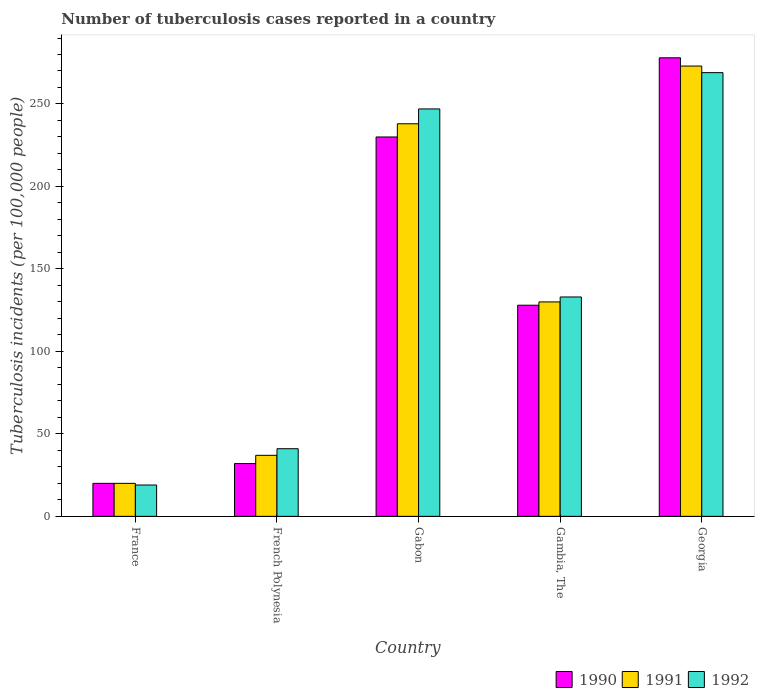How many bars are there on the 5th tick from the left?
Your answer should be very brief. 3. How many bars are there on the 3rd tick from the right?
Provide a short and direct response. 3. What is the label of the 4th group of bars from the left?
Ensure brevity in your answer.  Gambia, The. In how many cases, is the number of bars for a given country not equal to the number of legend labels?
Your answer should be very brief. 0. What is the number of tuberculosis cases reported in in 1990 in Gambia, The?
Provide a short and direct response. 128. Across all countries, what is the maximum number of tuberculosis cases reported in in 1991?
Keep it short and to the point. 273. In which country was the number of tuberculosis cases reported in in 1992 maximum?
Give a very brief answer. Georgia. What is the total number of tuberculosis cases reported in in 1991 in the graph?
Ensure brevity in your answer.  698. What is the difference between the number of tuberculosis cases reported in in 1990 in Gambia, The and that in Georgia?
Keep it short and to the point. -150. What is the difference between the number of tuberculosis cases reported in in 1990 in France and the number of tuberculosis cases reported in in 1992 in Georgia?
Offer a very short reply. -249. What is the average number of tuberculosis cases reported in in 1992 per country?
Make the answer very short. 141.8. What is the ratio of the number of tuberculosis cases reported in in 1991 in France to that in French Polynesia?
Ensure brevity in your answer.  0.54. Is the difference between the number of tuberculosis cases reported in in 1991 in France and Georgia greater than the difference between the number of tuberculosis cases reported in in 1992 in France and Georgia?
Provide a short and direct response. No. What is the difference between the highest and the second highest number of tuberculosis cases reported in in 1992?
Give a very brief answer. 136. What is the difference between the highest and the lowest number of tuberculosis cases reported in in 1991?
Provide a succinct answer. 253. In how many countries, is the number of tuberculosis cases reported in in 1990 greater than the average number of tuberculosis cases reported in in 1990 taken over all countries?
Offer a very short reply. 2. What does the 3rd bar from the right in Gambia, The represents?
Your answer should be very brief. 1990. Is it the case that in every country, the sum of the number of tuberculosis cases reported in in 1992 and number of tuberculosis cases reported in in 1991 is greater than the number of tuberculosis cases reported in in 1990?
Make the answer very short. Yes. What is the difference between two consecutive major ticks on the Y-axis?
Provide a succinct answer. 50. Are the values on the major ticks of Y-axis written in scientific E-notation?
Keep it short and to the point. No. Where does the legend appear in the graph?
Provide a short and direct response. Bottom right. How many legend labels are there?
Your response must be concise. 3. How are the legend labels stacked?
Your answer should be compact. Horizontal. What is the title of the graph?
Keep it short and to the point. Number of tuberculosis cases reported in a country. Does "1983" appear as one of the legend labels in the graph?
Provide a short and direct response. No. What is the label or title of the Y-axis?
Your answer should be very brief. Tuberculosis incidents (per 100,0 people). What is the Tuberculosis incidents (per 100,000 people) in 1990 in French Polynesia?
Keep it short and to the point. 32. What is the Tuberculosis incidents (per 100,000 people) of 1992 in French Polynesia?
Offer a very short reply. 41. What is the Tuberculosis incidents (per 100,000 people) in 1990 in Gabon?
Offer a very short reply. 230. What is the Tuberculosis incidents (per 100,000 people) of 1991 in Gabon?
Your response must be concise. 238. What is the Tuberculosis incidents (per 100,000 people) in 1992 in Gabon?
Offer a terse response. 247. What is the Tuberculosis incidents (per 100,000 people) in 1990 in Gambia, The?
Provide a succinct answer. 128. What is the Tuberculosis incidents (per 100,000 people) in 1991 in Gambia, The?
Your answer should be very brief. 130. What is the Tuberculosis incidents (per 100,000 people) in 1992 in Gambia, The?
Ensure brevity in your answer.  133. What is the Tuberculosis incidents (per 100,000 people) in 1990 in Georgia?
Offer a very short reply. 278. What is the Tuberculosis incidents (per 100,000 people) of 1991 in Georgia?
Your response must be concise. 273. What is the Tuberculosis incidents (per 100,000 people) in 1992 in Georgia?
Provide a short and direct response. 269. Across all countries, what is the maximum Tuberculosis incidents (per 100,000 people) of 1990?
Ensure brevity in your answer.  278. Across all countries, what is the maximum Tuberculosis incidents (per 100,000 people) of 1991?
Offer a very short reply. 273. Across all countries, what is the maximum Tuberculosis incidents (per 100,000 people) of 1992?
Keep it short and to the point. 269. Across all countries, what is the minimum Tuberculosis incidents (per 100,000 people) of 1992?
Make the answer very short. 19. What is the total Tuberculosis incidents (per 100,000 people) of 1990 in the graph?
Give a very brief answer. 688. What is the total Tuberculosis incidents (per 100,000 people) of 1991 in the graph?
Make the answer very short. 698. What is the total Tuberculosis incidents (per 100,000 people) of 1992 in the graph?
Offer a very short reply. 709. What is the difference between the Tuberculosis incidents (per 100,000 people) in 1990 in France and that in French Polynesia?
Your answer should be compact. -12. What is the difference between the Tuberculosis incidents (per 100,000 people) in 1991 in France and that in French Polynesia?
Your answer should be compact. -17. What is the difference between the Tuberculosis incidents (per 100,000 people) of 1992 in France and that in French Polynesia?
Offer a very short reply. -22. What is the difference between the Tuberculosis incidents (per 100,000 people) in 1990 in France and that in Gabon?
Make the answer very short. -210. What is the difference between the Tuberculosis incidents (per 100,000 people) of 1991 in France and that in Gabon?
Provide a succinct answer. -218. What is the difference between the Tuberculosis incidents (per 100,000 people) of 1992 in France and that in Gabon?
Give a very brief answer. -228. What is the difference between the Tuberculosis incidents (per 100,000 people) in 1990 in France and that in Gambia, The?
Provide a succinct answer. -108. What is the difference between the Tuberculosis incidents (per 100,000 people) in 1991 in France and that in Gambia, The?
Make the answer very short. -110. What is the difference between the Tuberculosis incidents (per 100,000 people) of 1992 in France and that in Gambia, The?
Provide a succinct answer. -114. What is the difference between the Tuberculosis incidents (per 100,000 people) of 1990 in France and that in Georgia?
Ensure brevity in your answer.  -258. What is the difference between the Tuberculosis incidents (per 100,000 people) of 1991 in France and that in Georgia?
Provide a short and direct response. -253. What is the difference between the Tuberculosis incidents (per 100,000 people) in 1992 in France and that in Georgia?
Keep it short and to the point. -250. What is the difference between the Tuberculosis incidents (per 100,000 people) of 1990 in French Polynesia and that in Gabon?
Offer a terse response. -198. What is the difference between the Tuberculosis incidents (per 100,000 people) of 1991 in French Polynesia and that in Gabon?
Keep it short and to the point. -201. What is the difference between the Tuberculosis incidents (per 100,000 people) in 1992 in French Polynesia and that in Gabon?
Provide a short and direct response. -206. What is the difference between the Tuberculosis incidents (per 100,000 people) of 1990 in French Polynesia and that in Gambia, The?
Keep it short and to the point. -96. What is the difference between the Tuberculosis incidents (per 100,000 people) of 1991 in French Polynesia and that in Gambia, The?
Your response must be concise. -93. What is the difference between the Tuberculosis incidents (per 100,000 people) of 1992 in French Polynesia and that in Gambia, The?
Offer a very short reply. -92. What is the difference between the Tuberculosis incidents (per 100,000 people) of 1990 in French Polynesia and that in Georgia?
Your response must be concise. -246. What is the difference between the Tuberculosis incidents (per 100,000 people) in 1991 in French Polynesia and that in Georgia?
Provide a succinct answer. -236. What is the difference between the Tuberculosis incidents (per 100,000 people) of 1992 in French Polynesia and that in Georgia?
Make the answer very short. -228. What is the difference between the Tuberculosis incidents (per 100,000 people) in 1990 in Gabon and that in Gambia, The?
Provide a succinct answer. 102. What is the difference between the Tuberculosis incidents (per 100,000 people) of 1991 in Gabon and that in Gambia, The?
Offer a terse response. 108. What is the difference between the Tuberculosis incidents (per 100,000 people) of 1992 in Gabon and that in Gambia, The?
Offer a very short reply. 114. What is the difference between the Tuberculosis incidents (per 100,000 people) in 1990 in Gabon and that in Georgia?
Provide a short and direct response. -48. What is the difference between the Tuberculosis incidents (per 100,000 people) in 1991 in Gabon and that in Georgia?
Give a very brief answer. -35. What is the difference between the Tuberculosis incidents (per 100,000 people) in 1990 in Gambia, The and that in Georgia?
Provide a short and direct response. -150. What is the difference between the Tuberculosis incidents (per 100,000 people) of 1991 in Gambia, The and that in Georgia?
Make the answer very short. -143. What is the difference between the Tuberculosis incidents (per 100,000 people) in 1992 in Gambia, The and that in Georgia?
Your answer should be compact. -136. What is the difference between the Tuberculosis incidents (per 100,000 people) in 1990 in France and the Tuberculosis incidents (per 100,000 people) in 1991 in French Polynesia?
Your answer should be very brief. -17. What is the difference between the Tuberculosis incidents (per 100,000 people) of 1990 in France and the Tuberculosis incidents (per 100,000 people) of 1991 in Gabon?
Make the answer very short. -218. What is the difference between the Tuberculosis incidents (per 100,000 people) of 1990 in France and the Tuberculosis incidents (per 100,000 people) of 1992 in Gabon?
Your answer should be compact. -227. What is the difference between the Tuberculosis incidents (per 100,000 people) in 1991 in France and the Tuberculosis incidents (per 100,000 people) in 1992 in Gabon?
Keep it short and to the point. -227. What is the difference between the Tuberculosis incidents (per 100,000 people) of 1990 in France and the Tuberculosis incidents (per 100,000 people) of 1991 in Gambia, The?
Your answer should be compact. -110. What is the difference between the Tuberculosis incidents (per 100,000 people) of 1990 in France and the Tuberculosis incidents (per 100,000 people) of 1992 in Gambia, The?
Provide a succinct answer. -113. What is the difference between the Tuberculosis incidents (per 100,000 people) of 1991 in France and the Tuberculosis incidents (per 100,000 people) of 1992 in Gambia, The?
Keep it short and to the point. -113. What is the difference between the Tuberculosis incidents (per 100,000 people) in 1990 in France and the Tuberculosis incidents (per 100,000 people) in 1991 in Georgia?
Your answer should be very brief. -253. What is the difference between the Tuberculosis incidents (per 100,000 people) of 1990 in France and the Tuberculosis incidents (per 100,000 people) of 1992 in Georgia?
Your answer should be very brief. -249. What is the difference between the Tuberculosis incidents (per 100,000 people) of 1991 in France and the Tuberculosis incidents (per 100,000 people) of 1992 in Georgia?
Offer a terse response. -249. What is the difference between the Tuberculosis incidents (per 100,000 people) in 1990 in French Polynesia and the Tuberculosis incidents (per 100,000 people) in 1991 in Gabon?
Offer a terse response. -206. What is the difference between the Tuberculosis incidents (per 100,000 people) in 1990 in French Polynesia and the Tuberculosis incidents (per 100,000 people) in 1992 in Gabon?
Keep it short and to the point. -215. What is the difference between the Tuberculosis incidents (per 100,000 people) in 1991 in French Polynesia and the Tuberculosis incidents (per 100,000 people) in 1992 in Gabon?
Offer a very short reply. -210. What is the difference between the Tuberculosis incidents (per 100,000 people) in 1990 in French Polynesia and the Tuberculosis incidents (per 100,000 people) in 1991 in Gambia, The?
Offer a very short reply. -98. What is the difference between the Tuberculosis incidents (per 100,000 people) of 1990 in French Polynesia and the Tuberculosis incidents (per 100,000 people) of 1992 in Gambia, The?
Provide a succinct answer. -101. What is the difference between the Tuberculosis incidents (per 100,000 people) in 1991 in French Polynesia and the Tuberculosis incidents (per 100,000 people) in 1992 in Gambia, The?
Give a very brief answer. -96. What is the difference between the Tuberculosis incidents (per 100,000 people) of 1990 in French Polynesia and the Tuberculosis incidents (per 100,000 people) of 1991 in Georgia?
Give a very brief answer. -241. What is the difference between the Tuberculosis incidents (per 100,000 people) in 1990 in French Polynesia and the Tuberculosis incidents (per 100,000 people) in 1992 in Georgia?
Your answer should be compact. -237. What is the difference between the Tuberculosis incidents (per 100,000 people) in 1991 in French Polynesia and the Tuberculosis incidents (per 100,000 people) in 1992 in Georgia?
Your response must be concise. -232. What is the difference between the Tuberculosis incidents (per 100,000 people) in 1990 in Gabon and the Tuberculosis incidents (per 100,000 people) in 1992 in Gambia, The?
Give a very brief answer. 97. What is the difference between the Tuberculosis incidents (per 100,000 people) in 1991 in Gabon and the Tuberculosis incidents (per 100,000 people) in 1992 in Gambia, The?
Make the answer very short. 105. What is the difference between the Tuberculosis incidents (per 100,000 people) of 1990 in Gabon and the Tuberculosis incidents (per 100,000 people) of 1991 in Georgia?
Provide a succinct answer. -43. What is the difference between the Tuberculosis incidents (per 100,000 people) of 1990 in Gabon and the Tuberculosis incidents (per 100,000 people) of 1992 in Georgia?
Provide a succinct answer. -39. What is the difference between the Tuberculosis incidents (per 100,000 people) of 1991 in Gabon and the Tuberculosis incidents (per 100,000 people) of 1992 in Georgia?
Keep it short and to the point. -31. What is the difference between the Tuberculosis incidents (per 100,000 people) of 1990 in Gambia, The and the Tuberculosis incidents (per 100,000 people) of 1991 in Georgia?
Offer a terse response. -145. What is the difference between the Tuberculosis incidents (per 100,000 people) of 1990 in Gambia, The and the Tuberculosis incidents (per 100,000 people) of 1992 in Georgia?
Your answer should be very brief. -141. What is the difference between the Tuberculosis incidents (per 100,000 people) of 1991 in Gambia, The and the Tuberculosis incidents (per 100,000 people) of 1992 in Georgia?
Your response must be concise. -139. What is the average Tuberculosis incidents (per 100,000 people) in 1990 per country?
Keep it short and to the point. 137.6. What is the average Tuberculosis incidents (per 100,000 people) in 1991 per country?
Make the answer very short. 139.6. What is the average Tuberculosis incidents (per 100,000 people) in 1992 per country?
Provide a succinct answer. 141.8. What is the difference between the Tuberculosis incidents (per 100,000 people) in 1990 and Tuberculosis incidents (per 100,000 people) in 1991 in France?
Offer a terse response. 0. What is the difference between the Tuberculosis incidents (per 100,000 people) of 1990 and Tuberculosis incidents (per 100,000 people) of 1992 in France?
Keep it short and to the point. 1. What is the difference between the Tuberculosis incidents (per 100,000 people) of 1991 and Tuberculosis incidents (per 100,000 people) of 1992 in France?
Offer a very short reply. 1. What is the difference between the Tuberculosis incidents (per 100,000 people) in 1990 and Tuberculosis incidents (per 100,000 people) in 1991 in French Polynesia?
Give a very brief answer. -5. What is the difference between the Tuberculosis incidents (per 100,000 people) in 1990 and Tuberculosis incidents (per 100,000 people) in 1992 in French Polynesia?
Keep it short and to the point. -9. What is the difference between the Tuberculosis incidents (per 100,000 people) of 1990 and Tuberculosis incidents (per 100,000 people) of 1991 in Gabon?
Offer a terse response. -8. What is the difference between the Tuberculosis incidents (per 100,000 people) of 1990 and Tuberculosis incidents (per 100,000 people) of 1992 in Gabon?
Your answer should be very brief. -17. What is the difference between the Tuberculosis incidents (per 100,000 people) of 1990 and Tuberculosis incidents (per 100,000 people) of 1991 in Georgia?
Your answer should be compact. 5. What is the difference between the Tuberculosis incidents (per 100,000 people) of 1991 and Tuberculosis incidents (per 100,000 people) of 1992 in Georgia?
Make the answer very short. 4. What is the ratio of the Tuberculosis incidents (per 100,000 people) in 1990 in France to that in French Polynesia?
Provide a short and direct response. 0.62. What is the ratio of the Tuberculosis incidents (per 100,000 people) in 1991 in France to that in French Polynesia?
Offer a terse response. 0.54. What is the ratio of the Tuberculosis incidents (per 100,000 people) of 1992 in France to that in French Polynesia?
Give a very brief answer. 0.46. What is the ratio of the Tuberculosis incidents (per 100,000 people) of 1990 in France to that in Gabon?
Provide a short and direct response. 0.09. What is the ratio of the Tuberculosis incidents (per 100,000 people) in 1991 in France to that in Gabon?
Your response must be concise. 0.08. What is the ratio of the Tuberculosis incidents (per 100,000 people) in 1992 in France to that in Gabon?
Keep it short and to the point. 0.08. What is the ratio of the Tuberculosis incidents (per 100,000 people) of 1990 in France to that in Gambia, The?
Give a very brief answer. 0.16. What is the ratio of the Tuberculosis incidents (per 100,000 people) in 1991 in France to that in Gambia, The?
Provide a succinct answer. 0.15. What is the ratio of the Tuberculosis incidents (per 100,000 people) in 1992 in France to that in Gambia, The?
Make the answer very short. 0.14. What is the ratio of the Tuberculosis incidents (per 100,000 people) in 1990 in France to that in Georgia?
Your answer should be very brief. 0.07. What is the ratio of the Tuberculosis incidents (per 100,000 people) of 1991 in France to that in Georgia?
Provide a succinct answer. 0.07. What is the ratio of the Tuberculosis incidents (per 100,000 people) of 1992 in France to that in Georgia?
Your response must be concise. 0.07. What is the ratio of the Tuberculosis incidents (per 100,000 people) in 1990 in French Polynesia to that in Gabon?
Keep it short and to the point. 0.14. What is the ratio of the Tuberculosis incidents (per 100,000 people) of 1991 in French Polynesia to that in Gabon?
Ensure brevity in your answer.  0.16. What is the ratio of the Tuberculosis incidents (per 100,000 people) of 1992 in French Polynesia to that in Gabon?
Your answer should be compact. 0.17. What is the ratio of the Tuberculosis incidents (per 100,000 people) in 1990 in French Polynesia to that in Gambia, The?
Make the answer very short. 0.25. What is the ratio of the Tuberculosis incidents (per 100,000 people) in 1991 in French Polynesia to that in Gambia, The?
Provide a succinct answer. 0.28. What is the ratio of the Tuberculosis incidents (per 100,000 people) of 1992 in French Polynesia to that in Gambia, The?
Make the answer very short. 0.31. What is the ratio of the Tuberculosis incidents (per 100,000 people) of 1990 in French Polynesia to that in Georgia?
Make the answer very short. 0.12. What is the ratio of the Tuberculosis incidents (per 100,000 people) of 1991 in French Polynesia to that in Georgia?
Offer a terse response. 0.14. What is the ratio of the Tuberculosis incidents (per 100,000 people) of 1992 in French Polynesia to that in Georgia?
Provide a succinct answer. 0.15. What is the ratio of the Tuberculosis incidents (per 100,000 people) in 1990 in Gabon to that in Gambia, The?
Ensure brevity in your answer.  1.8. What is the ratio of the Tuberculosis incidents (per 100,000 people) of 1991 in Gabon to that in Gambia, The?
Make the answer very short. 1.83. What is the ratio of the Tuberculosis incidents (per 100,000 people) in 1992 in Gabon to that in Gambia, The?
Your response must be concise. 1.86. What is the ratio of the Tuberculosis incidents (per 100,000 people) of 1990 in Gabon to that in Georgia?
Your response must be concise. 0.83. What is the ratio of the Tuberculosis incidents (per 100,000 people) in 1991 in Gabon to that in Georgia?
Give a very brief answer. 0.87. What is the ratio of the Tuberculosis incidents (per 100,000 people) in 1992 in Gabon to that in Georgia?
Provide a short and direct response. 0.92. What is the ratio of the Tuberculosis incidents (per 100,000 people) in 1990 in Gambia, The to that in Georgia?
Your answer should be very brief. 0.46. What is the ratio of the Tuberculosis incidents (per 100,000 people) in 1991 in Gambia, The to that in Georgia?
Make the answer very short. 0.48. What is the ratio of the Tuberculosis incidents (per 100,000 people) in 1992 in Gambia, The to that in Georgia?
Make the answer very short. 0.49. What is the difference between the highest and the second highest Tuberculosis incidents (per 100,000 people) in 1990?
Give a very brief answer. 48. What is the difference between the highest and the second highest Tuberculosis incidents (per 100,000 people) in 1991?
Give a very brief answer. 35. What is the difference between the highest and the lowest Tuberculosis incidents (per 100,000 people) of 1990?
Your answer should be compact. 258. What is the difference between the highest and the lowest Tuberculosis incidents (per 100,000 people) in 1991?
Make the answer very short. 253. What is the difference between the highest and the lowest Tuberculosis incidents (per 100,000 people) of 1992?
Your answer should be compact. 250. 